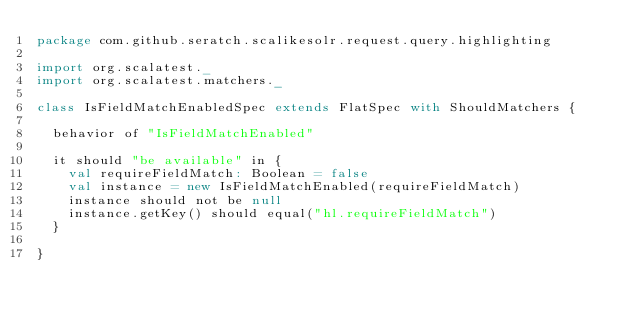Convert code to text. <code><loc_0><loc_0><loc_500><loc_500><_Scala_>package com.github.seratch.scalikesolr.request.query.highlighting

import org.scalatest._
import org.scalatest.matchers._

class IsFieldMatchEnabledSpec extends FlatSpec with ShouldMatchers {

  behavior of "IsFieldMatchEnabled"

  it should "be available" in {
    val requireFieldMatch: Boolean = false
    val instance = new IsFieldMatchEnabled(requireFieldMatch)
    instance should not be null
    instance.getKey() should equal("hl.requireFieldMatch")
  }

}
</code> 